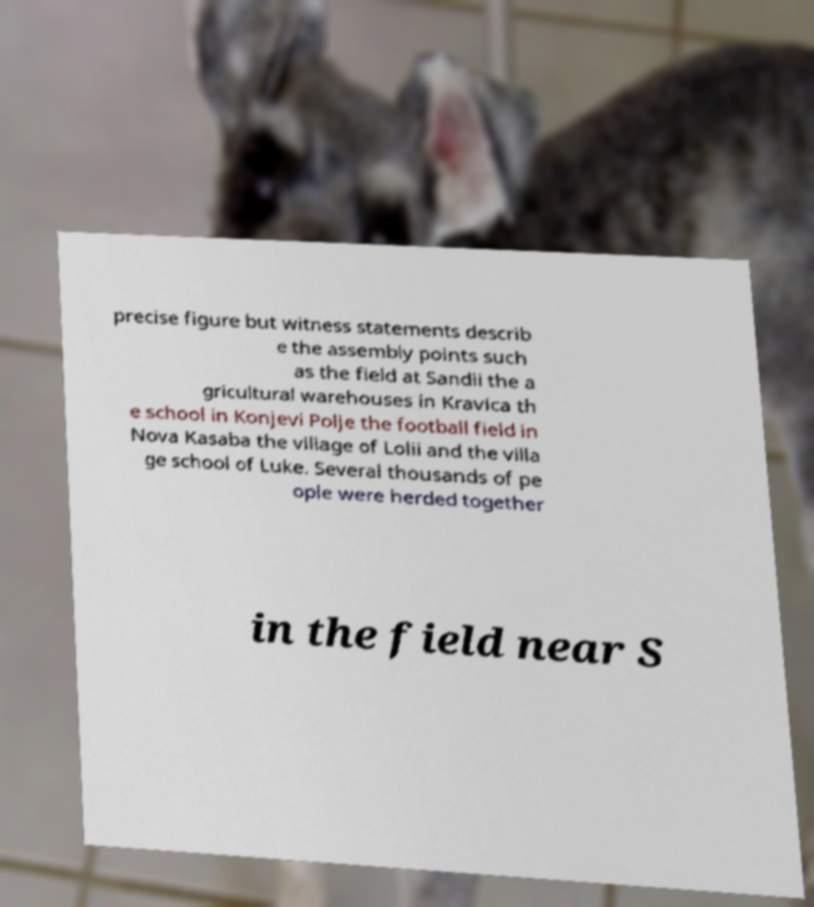Please identify and transcribe the text found in this image. precise figure but witness statements describ e the assembly points such as the field at Sandii the a gricultural warehouses in Kravica th e school in Konjevi Polje the football field in Nova Kasaba the village of Lolii and the villa ge school of Luke. Several thousands of pe ople were herded together in the field near S 